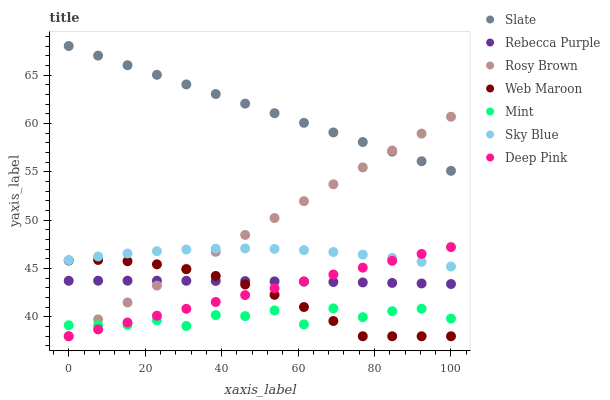Does Mint have the minimum area under the curve?
Answer yes or no. Yes. Does Slate have the maximum area under the curve?
Answer yes or no. Yes. Does Rosy Brown have the minimum area under the curve?
Answer yes or no. No. Does Rosy Brown have the maximum area under the curve?
Answer yes or no. No. Is Slate the smoothest?
Answer yes or no. Yes. Is Mint the roughest?
Answer yes or no. Yes. Is Rosy Brown the smoothest?
Answer yes or no. No. Is Rosy Brown the roughest?
Answer yes or no. No. Does Deep Pink have the lowest value?
Answer yes or no. Yes. Does Slate have the lowest value?
Answer yes or no. No. Does Slate have the highest value?
Answer yes or no. Yes. Does Rosy Brown have the highest value?
Answer yes or no. No. Is Mint less than Rebecca Purple?
Answer yes or no. Yes. Is Slate greater than Web Maroon?
Answer yes or no. Yes. Does Web Maroon intersect Rebecca Purple?
Answer yes or no. Yes. Is Web Maroon less than Rebecca Purple?
Answer yes or no. No. Is Web Maroon greater than Rebecca Purple?
Answer yes or no. No. Does Mint intersect Rebecca Purple?
Answer yes or no. No. 